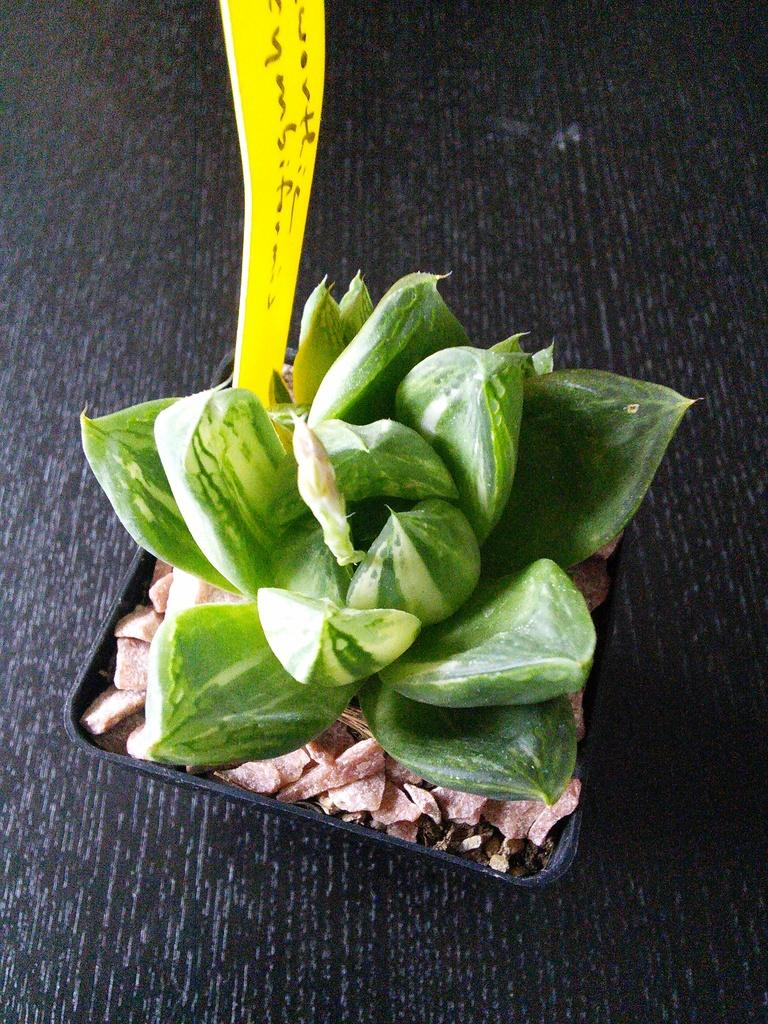What is the primary color of the object in the image? The primary color of the object in the image is black. What can be found inside the black object? There are green objects within the black object. What is the color of the other object in the image? The other object in the image is yellow. Can you describe the arrangement of the objects in the image? The black object with green objects inside is separate from the yellow object. Where is the baby in the image? There is no baby present in the image. What type of impulse can be seen affecting the objects in the image? There is no impulse affecting the objects in the image; they are stationary. 